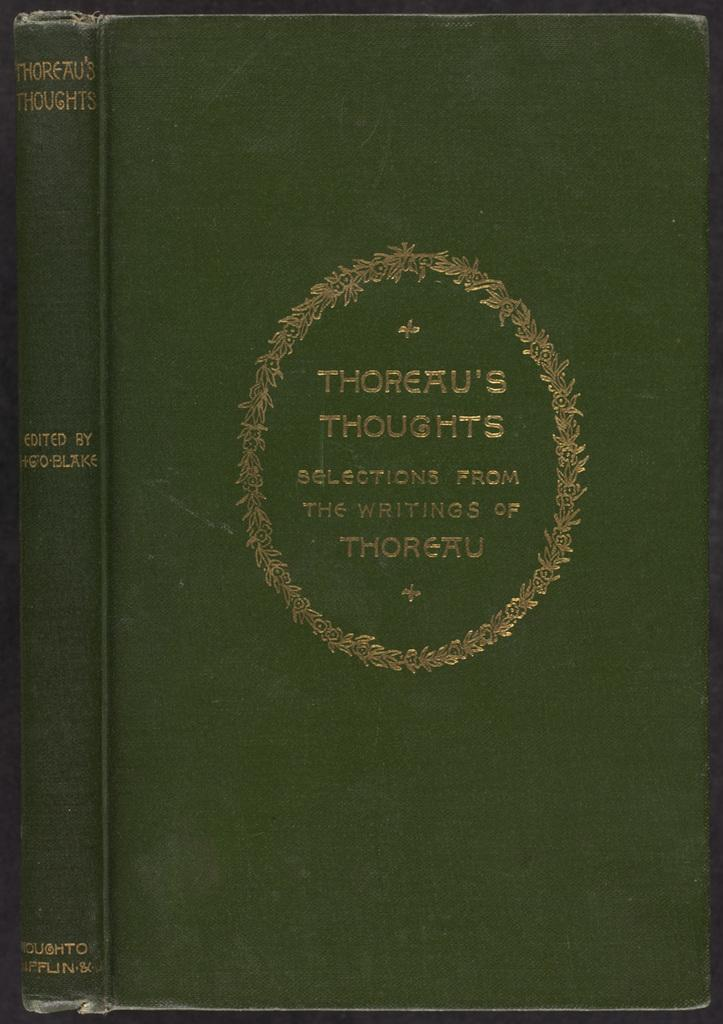<image>
Relay a brief, clear account of the picture shown. A book called selections from the writings of Thoreau 